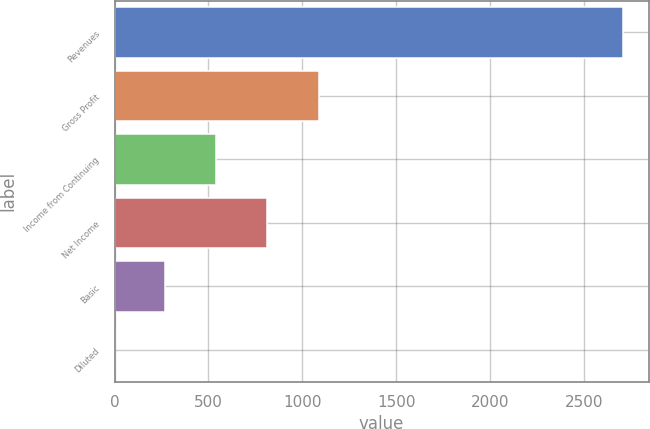Convert chart to OTSL. <chart><loc_0><loc_0><loc_500><loc_500><bar_chart><fcel>Revenues<fcel>Gross Profit<fcel>Income from Continuing<fcel>Net Income<fcel>Basic<fcel>Diluted<nl><fcel>2709.6<fcel>1088.1<fcel>542.36<fcel>813.26<fcel>271.46<fcel>0.56<nl></chart> 